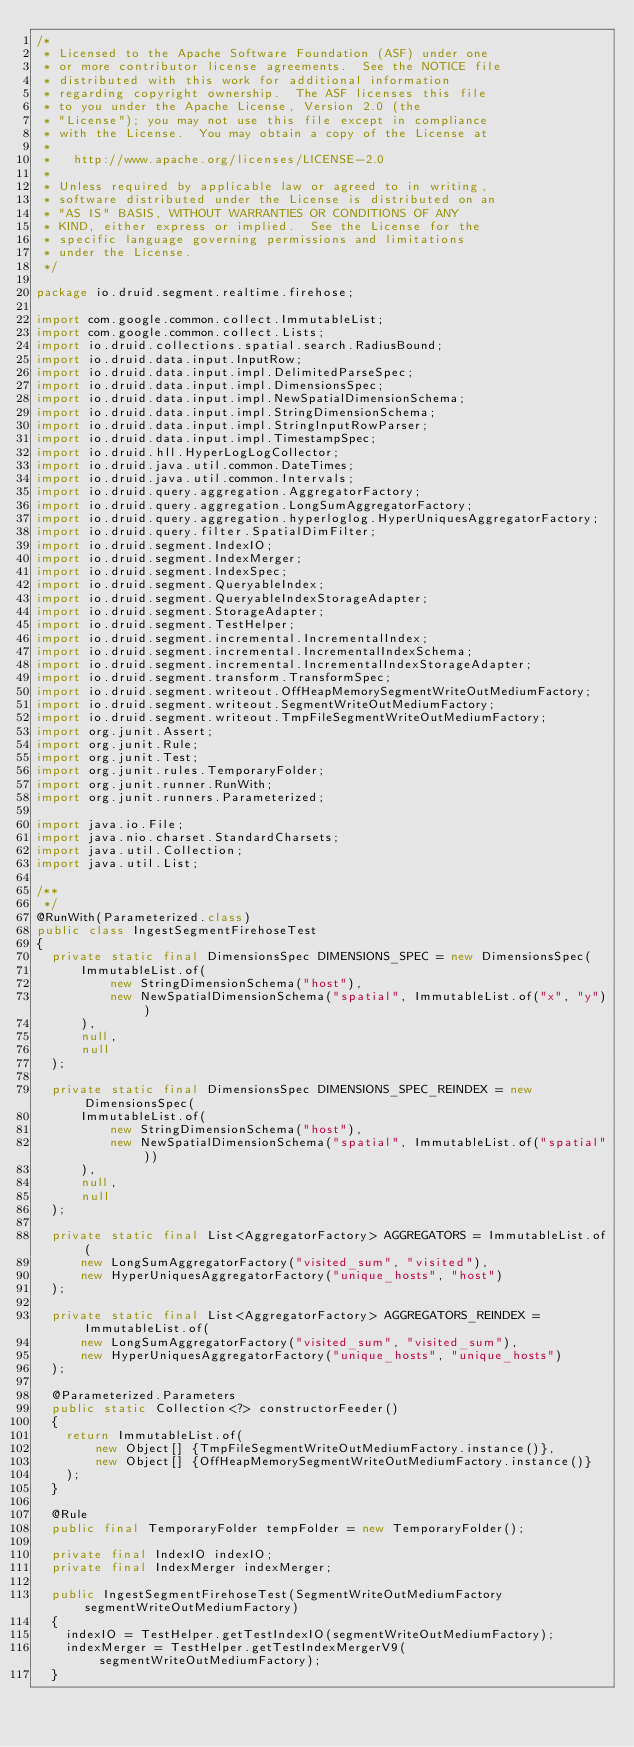Convert code to text. <code><loc_0><loc_0><loc_500><loc_500><_Java_>/*
 * Licensed to the Apache Software Foundation (ASF) under one
 * or more contributor license agreements.  See the NOTICE file
 * distributed with this work for additional information
 * regarding copyright ownership.  The ASF licenses this file
 * to you under the Apache License, Version 2.0 (the
 * "License"); you may not use this file except in compliance
 * with the License.  You may obtain a copy of the License at
 *
 *   http://www.apache.org/licenses/LICENSE-2.0
 *
 * Unless required by applicable law or agreed to in writing,
 * software distributed under the License is distributed on an
 * "AS IS" BASIS, WITHOUT WARRANTIES OR CONDITIONS OF ANY
 * KIND, either express or implied.  See the License for the
 * specific language governing permissions and limitations
 * under the License.
 */

package io.druid.segment.realtime.firehose;

import com.google.common.collect.ImmutableList;
import com.google.common.collect.Lists;
import io.druid.collections.spatial.search.RadiusBound;
import io.druid.data.input.InputRow;
import io.druid.data.input.impl.DelimitedParseSpec;
import io.druid.data.input.impl.DimensionsSpec;
import io.druid.data.input.impl.NewSpatialDimensionSchema;
import io.druid.data.input.impl.StringDimensionSchema;
import io.druid.data.input.impl.StringInputRowParser;
import io.druid.data.input.impl.TimestampSpec;
import io.druid.hll.HyperLogLogCollector;
import io.druid.java.util.common.DateTimes;
import io.druid.java.util.common.Intervals;
import io.druid.query.aggregation.AggregatorFactory;
import io.druid.query.aggregation.LongSumAggregatorFactory;
import io.druid.query.aggregation.hyperloglog.HyperUniquesAggregatorFactory;
import io.druid.query.filter.SpatialDimFilter;
import io.druid.segment.IndexIO;
import io.druid.segment.IndexMerger;
import io.druid.segment.IndexSpec;
import io.druid.segment.QueryableIndex;
import io.druid.segment.QueryableIndexStorageAdapter;
import io.druid.segment.StorageAdapter;
import io.druid.segment.TestHelper;
import io.druid.segment.incremental.IncrementalIndex;
import io.druid.segment.incremental.IncrementalIndexSchema;
import io.druid.segment.incremental.IncrementalIndexStorageAdapter;
import io.druid.segment.transform.TransformSpec;
import io.druid.segment.writeout.OffHeapMemorySegmentWriteOutMediumFactory;
import io.druid.segment.writeout.SegmentWriteOutMediumFactory;
import io.druid.segment.writeout.TmpFileSegmentWriteOutMediumFactory;
import org.junit.Assert;
import org.junit.Rule;
import org.junit.Test;
import org.junit.rules.TemporaryFolder;
import org.junit.runner.RunWith;
import org.junit.runners.Parameterized;

import java.io.File;
import java.nio.charset.StandardCharsets;
import java.util.Collection;
import java.util.List;

/**
 */
@RunWith(Parameterized.class)
public class IngestSegmentFirehoseTest
{
  private static final DimensionsSpec DIMENSIONS_SPEC = new DimensionsSpec(
      ImmutableList.of(
          new StringDimensionSchema("host"),
          new NewSpatialDimensionSchema("spatial", ImmutableList.of("x", "y"))
      ),
      null,
      null
  );

  private static final DimensionsSpec DIMENSIONS_SPEC_REINDEX = new DimensionsSpec(
      ImmutableList.of(
          new StringDimensionSchema("host"),
          new NewSpatialDimensionSchema("spatial", ImmutableList.of("spatial"))
      ),
      null,
      null
  );

  private static final List<AggregatorFactory> AGGREGATORS = ImmutableList.of(
      new LongSumAggregatorFactory("visited_sum", "visited"),
      new HyperUniquesAggregatorFactory("unique_hosts", "host")
  );

  private static final List<AggregatorFactory> AGGREGATORS_REINDEX = ImmutableList.of(
      new LongSumAggregatorFactory("visited_sum", "visited_sum"),
      new HyperUniquesAggregatorFactory("unique_hosts", "unique_hosts")
  );

  @Parameterized.Parameters
  public static Collection<?> constructorFeeder()
  {
    return ImmutableList.of(
        new Object[] {TmpFileSegmentWriteOutMediumFactory.instance()},
        new Object[] {OffHeapMemorySegmentWriteOutMediumFactory.instance()}
    );
  }

  @Rule
  public final TemporaryFolder tempFolder = new TemporaryFolder();

  private final IndexIO indexIO;
  private final IndexMerger indexMerger;

  public IngestSegmentFirehoseTest(SegmentWriteOutMediumFactory segmentWriteOutMediumFactory)
  {
    indexIO = TestHelper.getTestIndexIO(segmentWriteOutMediumFactory);
    indexMerger = TestHelper.getTestIndexMergerV9(segmentWriteOutMediumFactory);
  }
</code> 